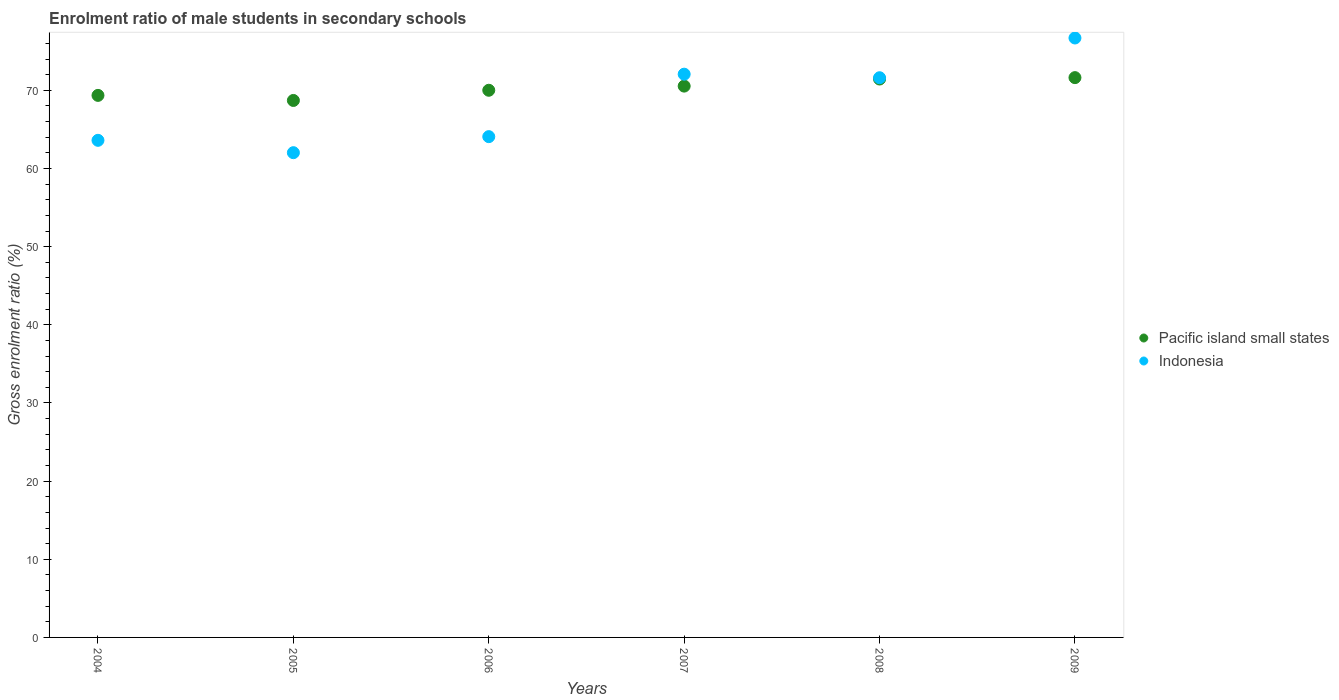Is the number of dotlines equal to the number of legend labels?
Provide a short and direct response. Yes. What is the enrolment ratio of male students in secondary schools in Pacific island small states in 2004?
Provide a succinct answer. 69.36. Across all years, what is the maximum enrolment ratio of male students in secondary schools in Indonesia?
Your response must be concise. 76.7. Across all years, what is the minimum enrolment ratio of male students in secondary schools in Indonesia?
Provide a short and direct response. 62.03. In which year was the enrolment ratio of male students in secondary schools in Indonesia maximum?
Offer a very short reply. 2009. In which year was the enrolment ratio of male students in secondary schools in Pacific island small states minimum?
Ensure brevity in your answer.  2005. What is the total enrolment ratio of male students in secondary schools in Pacific island small states in the graph?
Provide a short and direct response. 421.7. What is the difference between the enrolment ratio of male students in secondary schools in Indonesia in 2005 and that in 2009?
Your answer should be very brief. -14.68. What is the difference between the enrolment ratio of male students in secondary schools in Indonesia in 2004 and the enrolment ratio of male students in secondary schools in Pacific island small states in 2008?
Give a very brief answer. -7.84. What is the average enrolment ratio of male students in secondary schools in Pacific island small states per year?
Ensure brevity in your answer.  70.28. In the year 2008, what is the difference between the enrolment ratio of male students in secondary schools in Pacific island small states and enrolment ratio of male students in secondary schools in Indonesia?
Provide a short and direct response. -0.17. In how many years, is the enrolment ratio of male students in secondary schools in Pacific island small states greater than 44 %?
Your answer should be very brief. 6. What is the ratio of the enrolment ratio of male students in secondary schools in Indonesia in 2004 to that in 2007?
Keep it short and to the point. 0.88. What is the difference between the highest and the second highest enrolment ratio of male students in secondary schools in Indonesia?
Your answer should be compact. 4.63. What is the difference between the highest and the lowest enrolment ratio of male students in secondary schools in Pacific island small states?
Your answer should be very brief. 2.92. In how many years, is the enrolment ratio of male students in secondary schools in Indonesia greater than the average enrolment ratio of male students in secondary schools in Indonesia taken over all years?
Make the answer very short. 3. Does the enrolment ratio of male students in secondary schools in Indonesia monotonically increase over the years?
Give a very brief answer. No. How many years are there in the graph?
Make the answer very short. 6. Are the values on the major ticks of Y-axis written in scientific E-notation?
Offer a terse response. No. Does the graph contain any zero values?
Offer a very short reply. No. Does the graph contain grids?
Your answer should be compact. No. Where does the legend appear in the graph?
Ensure brevity in your answer.  Center right. What is the title of the graph?
Ensure brevity in your answer.  Enrolment ratio of male students in secondary schools. What is the label or title of the X-axis?
Ensure brevity in your answer.  Years. What is the Gross enrolment ratio (%) in Pacific island small states in 2004?
Make the answer very short. 69.36. What is the Gross enrolment ratio (%) of Indonesia in 2004?
Your response must be concise. 63.61. What is the Gross enrolment ratio (%) in Pacific island small states in 2005?
Provide a succinct answer. 68.71. What is the Gross enrolment ratio (%) of Indonesia in 2005?
Ensure brevity in your answer.  62.03. What is the Gross enrolment ratio (%) of Pacific island small states in 2006?
Your answer should be compact. 70.01. What is the Gross enrolment ratio (%) of Indonesia in 2006?
Keep it short and to the point. 64.08. What is the Gross enrolment ratio (%) of Pacific island small states in 2007?
Make the answer very short. 70.54. What is the Gross enrolment ratio (%) in Indonesia in 2007?
Give a very brief answer. 72.07. What is the Gross enrolment ratio (%) in Pacific island small states in 2008?
Ensure brevity in your answer.  71.45. What is the Gross enrolment ratio (%) of Indonesia in 2008?
Offer a very short reply. 71.62. What is the Gross enrolment ratio (%) of Pacific island small states in 2009?
Keep it short and to the point. 71.63. What is the Gross enrolment ratio (%) of Indonesia in 2009?
Provide a succinct answer. 76.7. Across all years, what is the maximum Gross enrolment ratio (%) in Pacific island small states?
Your answer should be compact. 71.63. Across all years, what is the maximum Gross enrolment ratio (%) in Indonesia?
Your response must be concise. 76.7. Across all years, what is the minimum Gross enrolment ratio (%) in Pacific island small states?
Your answer should be compact. 68.71. Across all years, what is the minimum Gross enrolment ratio (%) of Indonesia?
Provide a succinct answer. 62.03. What is the total Gross enrolment ratio (%) in Pacific island small states in the graph?
Offer a very short reply. 421.7. What is the total Gross enrolment ratio (%) of Indonesia in the graph?
Keep it short and to the point. 410.09. What is the difference between the Gross enrolment ratio (%) in Pacific island small states in 2004 and that in 2005?
Offer a terse response. 0.65. What is the difference between the Gross enrolment ratio (%) of Indonesia in 2004 and that in 2005?
Give a very brief answer. 1.58. What is the difference between the Gross enrolment ratio (%) of Pacific island small states in 2004 and that in 2006?
Your response must be concise. -0.66. What is the difference between the Gross enrolment ratio (%) in Indonesia in 2004 and that in 2006?
Ensure brevity in your answer.  -0.47. What is the difference between the Gross enrolment ratio (%) of Pacific island small states in 2004 and that in 2007?
Keep it short and to the point. -1.19. What is the difference between the Gross enrolment ratio (%) in Indonesia in 2004 and that in 2007?
Make the answer very short. -8.46. What is the difference between the Gross enrolment ratio (%) of Pacific island small states in 2004 and that in 2008?
Your answer should be compact. -2.09. What is the difference between the Gross enrolment ratio (%) in Indonesia in 2004 and that in 2008?
Your answer should be compact. -8.01. What is the difference between the Gross enrolment ratio (%) of Pacific island small states in 2004 and that in 2009?
Your answer should be compact. -2.27. What is the difference between the Gross enrolment ratio (%) in Indonesia in 2004 and that in 2009?
Give a very brief answer. -13.1. What is the difference between the Gross enrolment ratio (%) in Pacific island small states in 2005 and that in 2006?
Your answer should be very brief. -1.3. What is the difference between the Gross enrolment ratio (%) of Indonesia in 2005 and that in 2006?
Keep it short and to the point. -2.05. What is the difference between the Gross enrolment ratio (%) of Pacific island small states in 2005 and that in 2007?
Provide a short and direct response. -1.84. What is the difference between the Gross enrolment ratio (%) of Indonesia in 2005 and that in 2007?
Offer a very short reply. -10.04. What is the difference between the Gross enrolment ratio (%) of Pacific island small states in 2005 and that in 2008?
Make the answer very short. -2.74. What is the difference between the Gross enrolment ratio (%) in Indonesia in 2005 and that in 2008?
Provide a succinct answer. -9.59. What is the difference between the Gross enrolment ratio (%) in Pacific island small states in 2005 and that in 2009?
Your response must be concise. -2.92. What is the difference between the Gross enrolment ratio (%) in Indonesia in 2005 and that in 2009?
Make the answer very short. -14.68. What is the difference between the Gross enrolment ratio (%) of Pacific island small states in 2006 and that in 2007?
Make the answer very short. -0.53. What is the difference between the Gross enrolment ratio (%) in Indonesia in 2006 and that in 2007?
Offer a terse response. -7.99. What is the difference between the Gross enrolment ratio (%) in Pacific island small states in 2006 and that in 2008?
Provide a succinct answer. -1.44. What is the difference between the Gross enrolment ratio (%) in Indonesia in 2006 and that in 2008?
Ensure brevity in your answer.  -7.54. What is the difference between the Gross enrolment ratio (%) in Pacific island small states in 2006 and that in 2009?
Your response must be concise. -1.62. What is the difference between the Gross enrolment ratio (%) in Indonesia in 2006 and that in 2009?
Make the answer very short. -12.62. What is the difference between the Gross enrolment ratio (%) of Pacific island small states in 2007 and that in 2008?
Keep it short and to the point. -0.91. What is the difference between the Gross enrolment ratio (%) of Indonesia in 2007 and that in 2008?
Offer a terse response. 0.45. What is the difference between the Gross enrolment ratio (%) of Pacific island small states in 2007 and that in 2009?
Ensure brevity in your answer.  -1.08. What is the difference between the Gross enrolment ratio (%) in Indonesia in 2007 and that in 2009?
Your answer should be compact. -4.63. What is the difference between the Gross enrolment ratio (%) of Pacific island small states in 2008 and that in 2009?
Keep it short and to the point. -0.18. What is the difference between the Gross enrolment ratio (%) of Indonesia in 2008 and that in 2009?
Offer a terse response. -5.09. What is the difference between the Gross enrolment ratio (%) of Pacific island small states in 2004 and the Gross enrolment ratio (%) of Indonesia in 2005?
Offer a terse response. 7.33. What is the difference between the Gross enrolment ratio (%) in Pacific island small states in 2004 and the Gross enrolment ratio (%) in Indonesia in 2006?
Ensure brevity in your answer.  5.28. What is the difference between the Gross enrolment ratio (%) of Pacific island small states in 2004 and the Gross enrolment ratio (%) of Indonesia in 2007?
Offer a very short reply. -2.71. What is the difference between the Gross enrolment ratio (%) of Pacific island small states in 2004 and the Gross enrolment ratio (%) of Indonesia in 2008?
Your response must be concise. -2.26. What is the difference between the Gross enrolment ratio (%) of Pacific island small states in 2004 and the Gross enrolment ratio (%) of Indonesia in 2009?
Give a very brief answer. -7.35. What is the difference between the Gross enrolment ratio (%) of Pacific island small states in 2005 and the Gross enrolment ratio (%) of Indonesia in 2006?
Your response must be concise. 4.63. What is the difference between the Gross enrolment ratio (%) in Pacific island small states in 2005 and the Gross enrolment ratio (%) in Indonesia in 2007?
Provide a short and direct response. -3.36. What is the difference between the Gross enrolment ratio (%) of Pacific island small states in 2005 and the Gross enrolment ratio (%) of Indonesia in 2008?
Your answer should be very brief. -2.91. What is the difference between the Gross enrolment ratio (%) in Pacific island small states in 2005 and the Gross enrolment ratio (%) in Indonesia in 2009?
Your answer should be very brief. -7.99. What is the difference between the Gross enrolment ratio (%) in Pacific island small states in 2006 and the Gross enrolment ratio (%) in Indonesia in 2007?
Provide a succinct answer. -2.06. What is the difference between the Gross enrolment ratio (%) in Pacific island small states in 2006 and the Gross enrolment ratio (%) in Indonesia in 2008?
Offer a very short reply. -1.6. What is the difference between the Gross enrolment ratio (%) in Pacific island small states in 2006 and the Gross enrolment ratio (%) in Indonesia in 2009?
Make the answer very short. -6.69. What is the difference between the Gross enrolment ratio (%) of Pacific island small states in 2007 and the Gross enrolment ratio (%) of Indonesia in 2008?
Your response must be concise. -1.07. What is the difference between the Gross enrolment ratio (%) in Pacific island small states in 2007 and the Gross enrolment ratio (%) in Indonesia in 2009?
Make the answer very short. -6.16. What is the difference between the Gross enrolment ratio (%) of Pacific island small states in 2008 and the Gross enrolment ratio (%) of Indonesia in 2009?
Your answer should be compact. -5.25. What is the average Gross enrolment ratio (%) of Pacific island small states per year?
Make the answer very short. 70.28. What is the average Gross enrolment ratio (%) in Indonesia per year?
Keep it short and to the point. 68.35. In the year 2004, what is the difference between the Gross enrolment ratio (%) of Pacific island small states and Gross enrolment ratio (%) of Indonesia?
Ensure brevity in your answer.  5.75. In the year 2005, what is the difference between the Gross enrolment ratio (%) of Pacific island small states and Gross enrolment ratio (%) of Indonesia?
Your response must be concise. 6.68. In the year 2006, what is the difference between the Gross enrolment ratio (%) of Pacific island small states and Gross enrolment ratio (%) of Indonesia?
Your response must be concise. 5.93. In the year 2007, what is the difference between the Gross enrolment ratio (%) in Pacific island small states and Gross enrolment ratio (%) in Indonesia?
Ensure brevity in your answer.  -1.53. In the year 2008, what is the difference between the Gross enrolment ratio (%) of Pacific island small states and Gross enrolment ratio (%) of Indonesia?
Offer a terse response. -0.17. In the year 2009, what is the difference between the Gross enrolment ratio (%) of Pacific island small states and Gross enrolment ratio (%) of Indonesia?
Keep it short and to the point. -5.07. What is the ratio of the Gross enrolment ratio (%) of Pacific island small states in 2004 to that in 2005?
Ensure brevity in your answer.  1.01. What is the ratio of the Gross enrolment ratio (%) in Indonesia in 2004 to that in 2005?
Give a very brief answer. 1.03. What is the ratio of the Gross enrolment ratio (%) of Pacific island small states in 2004 to that in 2006?
Offer a terse response. 0.99. What is the ratio of the Gross enrolment ratio (%) in Indonesia in 2004 to that in 2006?
Provide a short and direct response. 0.99. What is the ratio of the Gross enrolment ratio (%) of Pacific island small states in 2004 to that in 2007?
Your answer should be compact. 0.98. What is the ratio of the Gross enrolment ratio (%) of Indonesia in 2004 to that in 2007?
Keep it short and to the point. 0.88. What is the ratio of the Gross enrolment ratio (%) in Pacific island small states in 2004 to that in 2008?
Make the answer very short. 0.97. What is the ratio of the Gross enrolment ratio (%) in Indonesia in 2004 to that in 2008?
Offer a very short reply. 0.89. What is the ratio of the Gross enrolment ratio (%) of Pacific island small states in 2004 to that in 2009?
Provide a short and direct response. 0.97. What is the ratio of the Gross enrolment ratio (%) of Indonesia in 2004 to that in 2009?
Offer a terse response. 0.83. What is the ratio of the Gross enrolment ratio (%) of Pacific island small states in 2005 to that in 2006?
Ensure brevity in your answer.  0.98. What is the ratio of the Gross enrolment ratio (%) of Indonesia in 2005 to that in 2006?
Give a very brief answer. 0.97. What is the ratio of the Gross enrolment ratio (%) of Indonesia in 2005 to that in 2007?
Your answer should be compact. 0.86. What is the ratio of the Gross enrolment ratio (%) of Pacific island small states in 2005 to that in 2008?
Your response must be concise. 0.96. What is the ratio of the Gross enrolment ratio (%) of Indonesia in 2005 to that in 2008?
Give a very brief answer. 0.87. What is the ratio of the Gross enrolment ratio (%) in Pacific island small states in 2005 to that in 2009?
Provide a succinct answer. 0.96. What is the ratio of the Gross enrolment ratio (%) in Indonesia in 2005 to that in 2009?
Provide a succinct answer. 0.81. What is the ratio of the Gross enrolment ratio (%) in Indonesia in 2006 to that in 2007?
Make the answer very short. 0.89. What is the ratio of the Gross enrolment ratio (%) in Pacific island small states in 2006 to that in 2008?
Your answer should be very brief. 0.98. What is the ratio of the Gross enrolment ratio (%) of Indonesia in 2006 to that in 2008?
Provide a succinct answer. 0.89. What is the ratio of the Gross enrolment ratio (%) in Pacific island small states in 2006 to that in 2009?
Your answer should be compact. 0.98. What is the ratio of the Gross enrolment ratio (%) of Indonesia in 2006 to that in 2009?
Your response must be concise. 0.84. What is the ratio of the Gross enrolment ratio (%) of Pacific island small states in 2007 to that in 2008?
Provide a succinct answer. 0.99. What is the ratio of the Gross enrolment ratio (%) of Indonesia in 2007 to that in 2008?
Offer a terse response. 1.01. What is the ratio of the Gross enrolment ratio (%) in Pacific island small states in 2007 to that in 2009?
Your response must be concise. 0.98. What is the ratio of the Gross enrolment ratio (%) of Indonesia in 2007 to that in 2009?
Provide a succinct answer. 0.94. What is the ratio of the Gross enrolment ratio (%) in Indonesia in 2008 to that in 2009?
Your response must be concise. 0.93. What is the difference between the highest and the second highest Gross enrolment ratio (%) of Pacific island small states?
Offer a very short reply. 0.18. What is the difference between the highest and the second highest Gross enrolment ratio (%) in Indonesia?
Make the answer very short. 4.63. What is the difference between the highest and the lowest Gross enrolment ratio (%) in Pacific island small states?
Provide a short and direct response. 2.92. What is the difference between the highest and the lowest Gross enrolment ratio (%) of Indonesia?
Give a very brief answer. 14.68. 